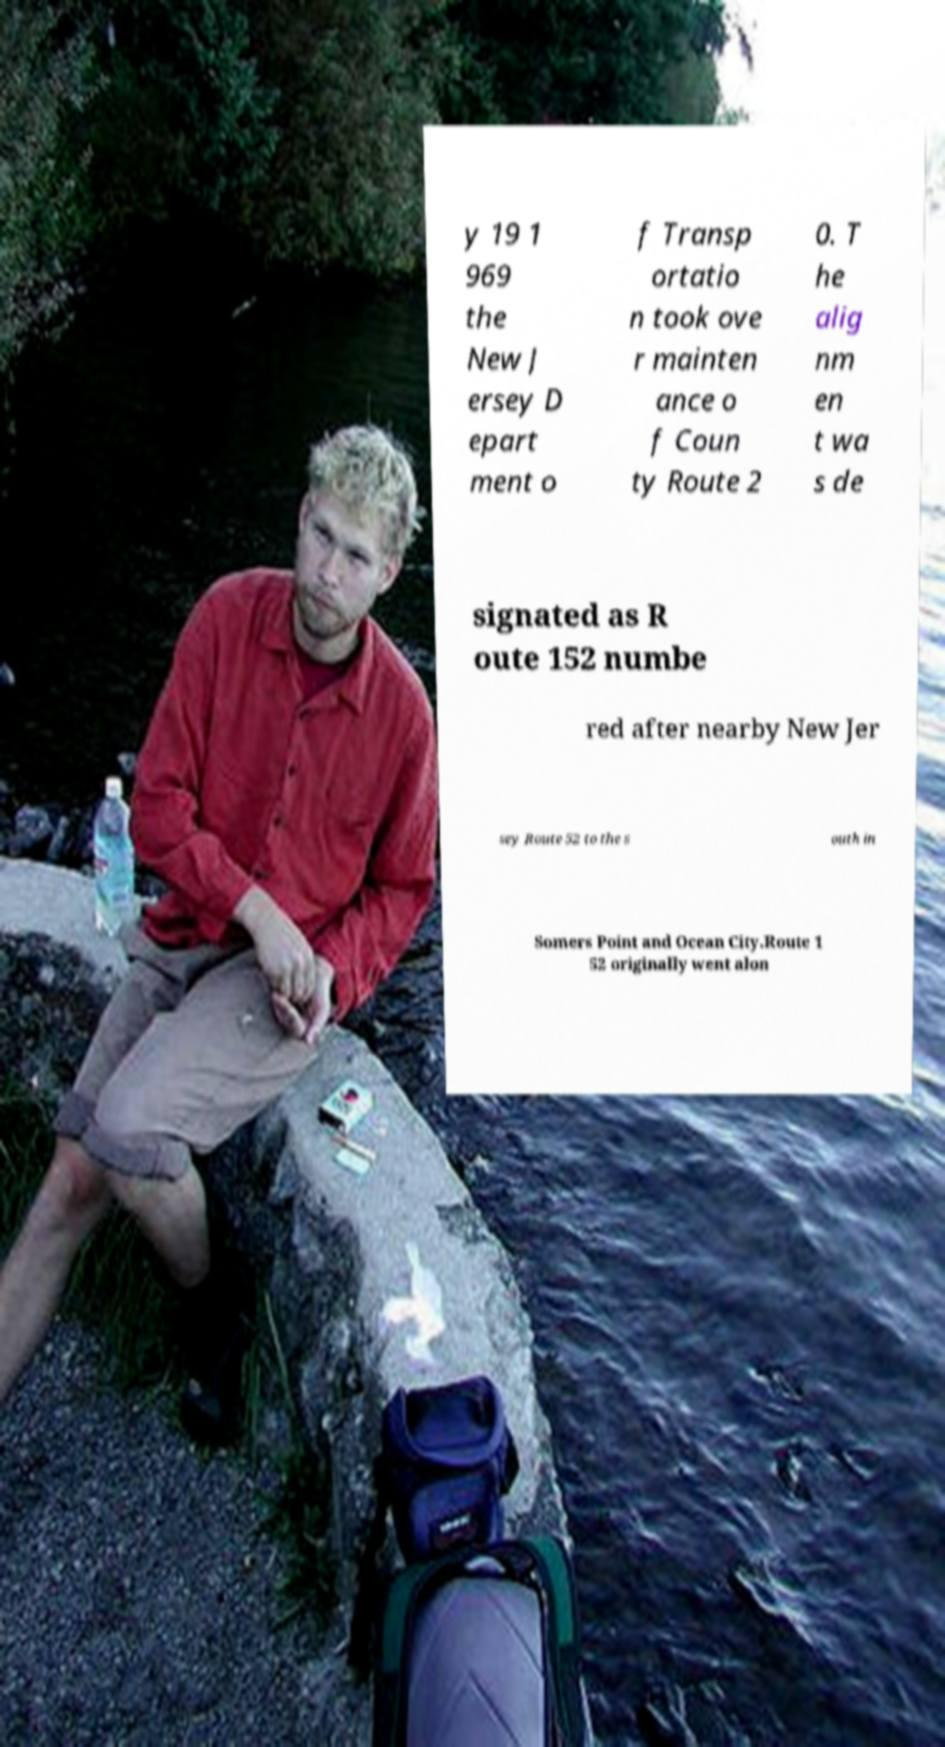There's text embedded in this image that I need extracted. Can you transcribe it verbatim? y 19 1 969 the New J ersey D epart ment o f Transp ortatio n took ove r mainten ance o f Coun ty Route 2 0. T he alig nm en t wa s de signated as R oute 152 numbe red after nearby New Jer sey Route 52 to the s outh in Somers Point and Ocean City.Route 1 52 originally went alon 